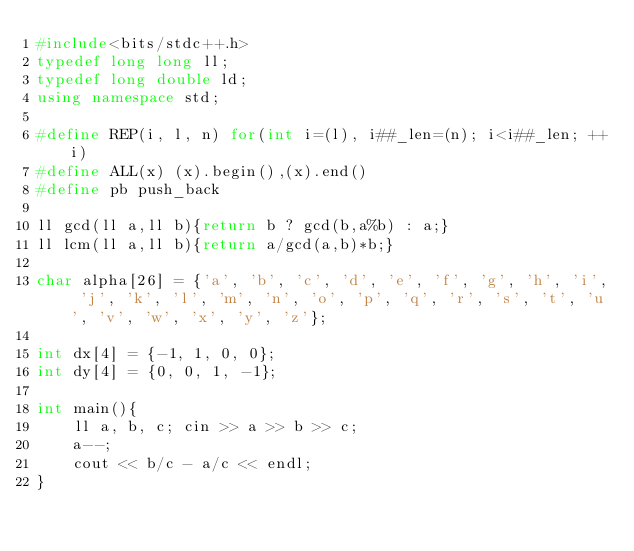Convert code to text. <code><loc_0><loc_0><loc_500><loc_500><_C++_>#include<bits/stdc++.h>
typedef long long ll;
typedef long double ld;
using namespace std;

#define REP(i, l, n) for(int i=(l), i##_len=(n); i<i##_len; ++i)
#define ALL(x) (x).begin(),(x).end()
#define pb push_back

ll gcd(ll a,ll b){return b ? gcd(b,a%b) : a;}
ll lcm(ll a,ll b){return a/gcd(a,b)*b;}

char alpha[26] = {'a', 'b', 'c', 'd', 'e', 'f', 'g', 'h', 'i', 'j', 'k', 'l', 'm', 'n', 'o', 'p', 'q', 'r', 's', 't', 'u', 'v', 'w', 'x', 'y', 'z'};

int dx[4] = {-1, 1, 0, 0};
int dy[4] = {0, 0, 1, -1};

int main(){
    ll a, b, c; cin >> a >> b >> c;
    a--;
    cout << b/c - a/c << endl;
}</code> 